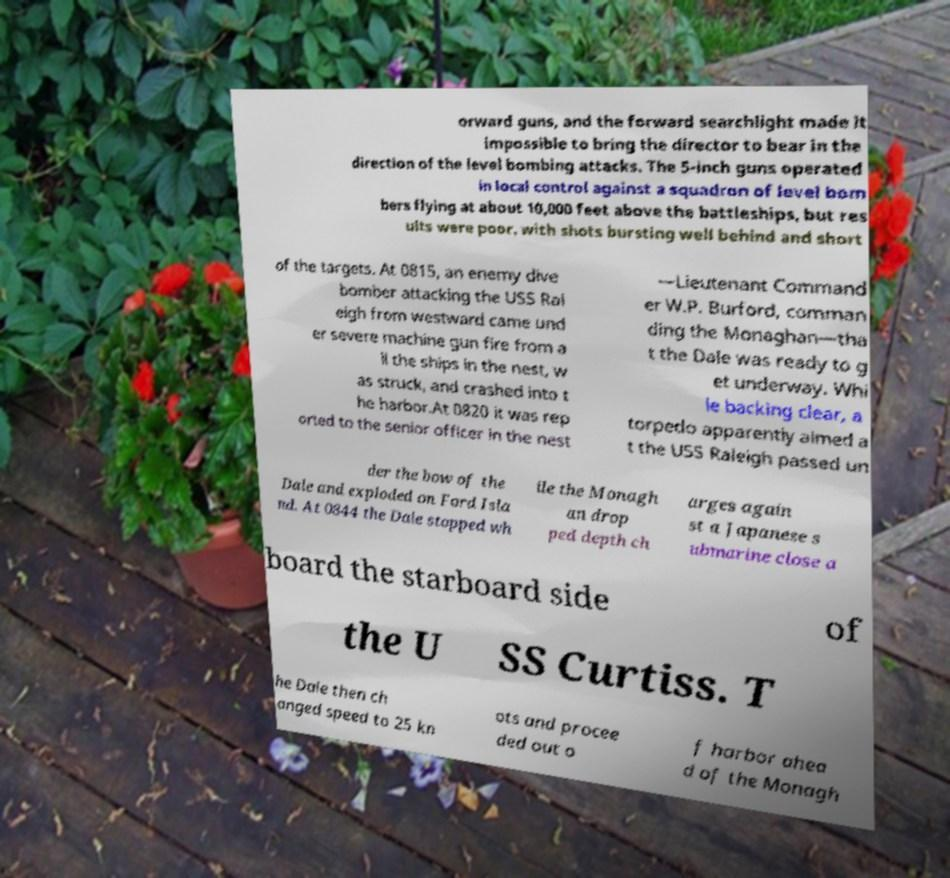What messages or text are displayed in this image? I need them in a readable, typed format. orward guns, and the forward searchlight made it impossible to bring the director to bear in the direction of the level bombing attacks. The 5-inch guns operated in local control against a squadron of level bom bers flying at about 10,000 feet above the battleships, but res ults were poor, with shots bursting well behind and short of the targets. At 0815, an enemy dive bomber attacking the USS Ral eigh from westward came und er severe machine gun fire from a ll the ships in the nest, w as struck, and crashed into t he harbor.At 0820 it was rep orted to the senior officer in the nest —Lieutenant Command er W.P. Burford, comman ding the Monaghan—tha t the Dale was ready to g et underway. Whi le backing clear, a torpedo apparently aimed a t the USS Raleigh passed un der the bow of the Dale and exploded on Ford Isla nd. At 0844 the Dale stopped wh ile the Monagh an drop ped depth ch arges again st a Japanese s ubmarine close a board the starboard side of the U SS Curtiss. T he Dale then ch anged speed to 25 kn ots and procee ded out o f harbor ahea d of the Monagh 